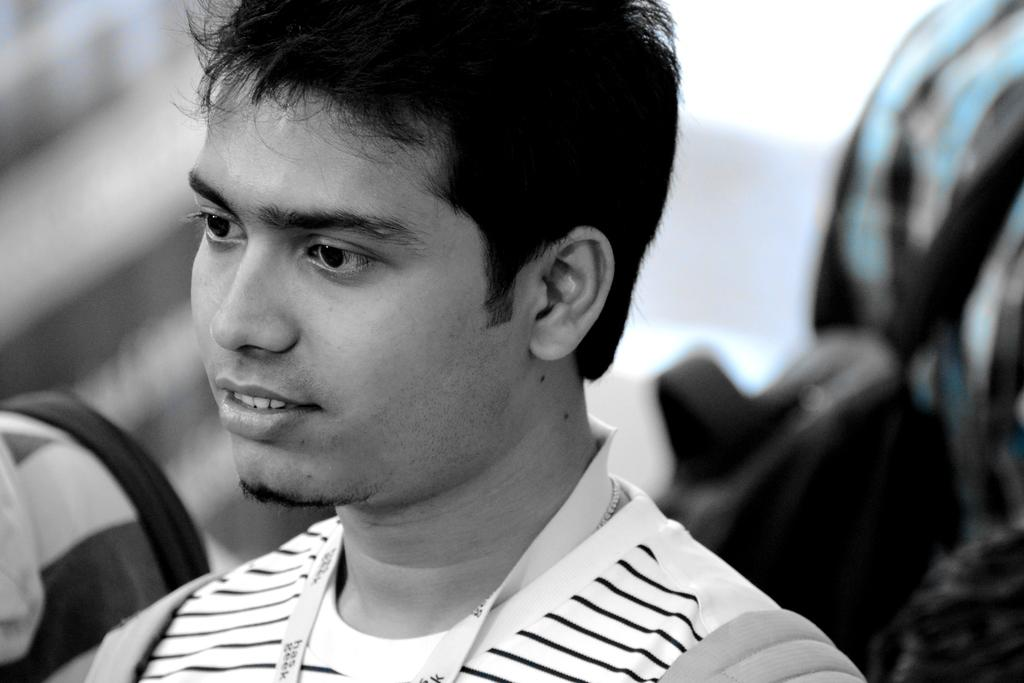What is the color scheme of the image? The image is black and white. Can you describe the main subject in the image? There is a man in the image. What can be observed about the background in the image? The background behind the man is blurred. What type of train can be seen in the background of the image? There is no train present in the image; it is a black and white image of a man with a blurred background. What is the man doing with his mouth in the image? The image is in black and white and does not show the man's mouth or any actions related to it. 